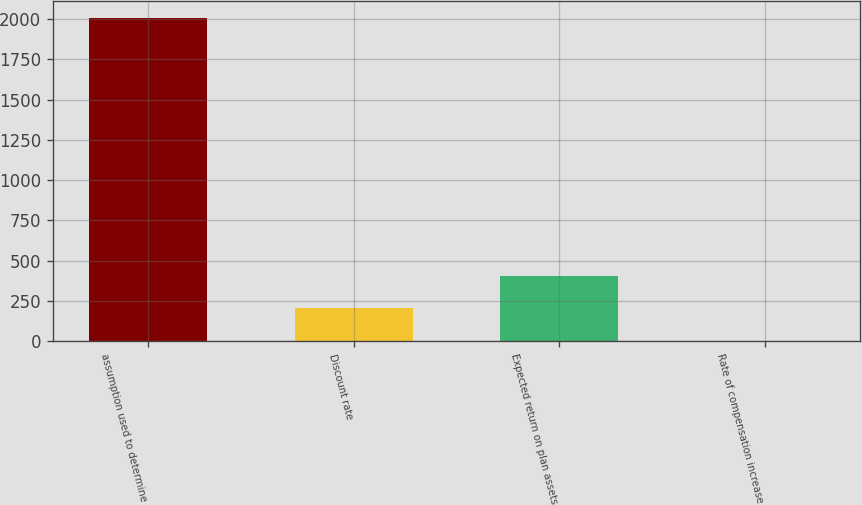<chart> <loc_0><loc_0><loc_500><loc_500><bar_chart><fcel>assumption used to determine<fcel>Discount rate<fcel>Expected return on plan assets<fcel>Rate of compensation increase<nl><fcel>2010<fcel>203.93<fcel>404.61<fcel>3.25<nl></chart> 